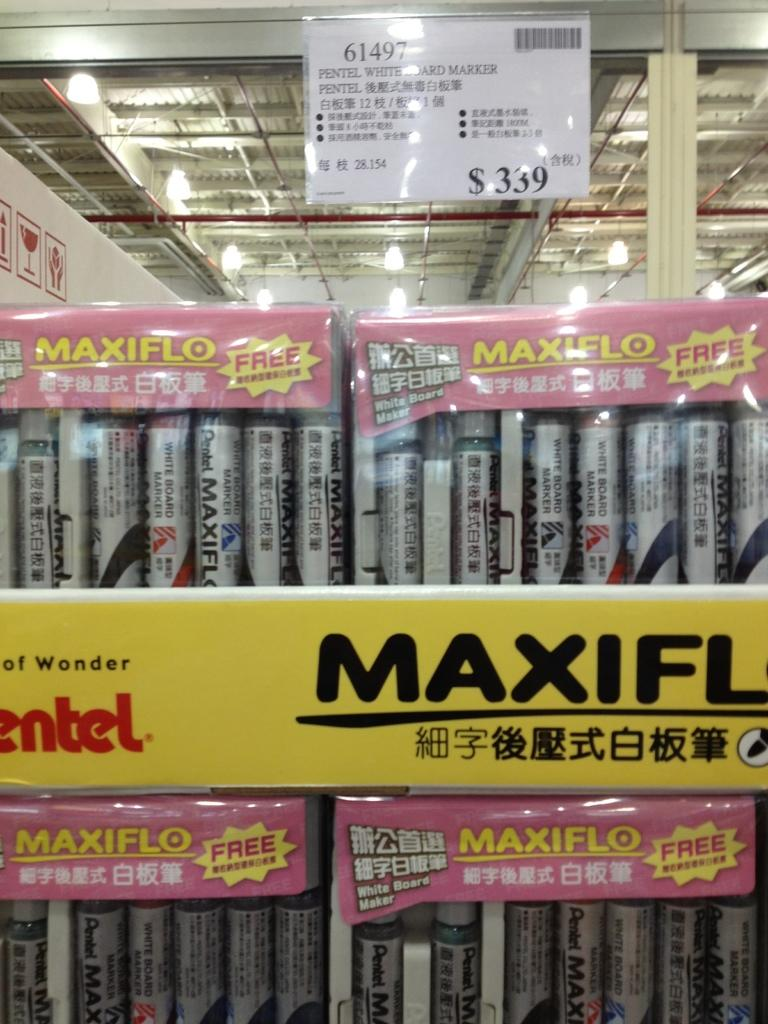<image>
Share a concise interpretation of the image provided. Pentel White Board Marker that consists of the brand Maxiflo. 